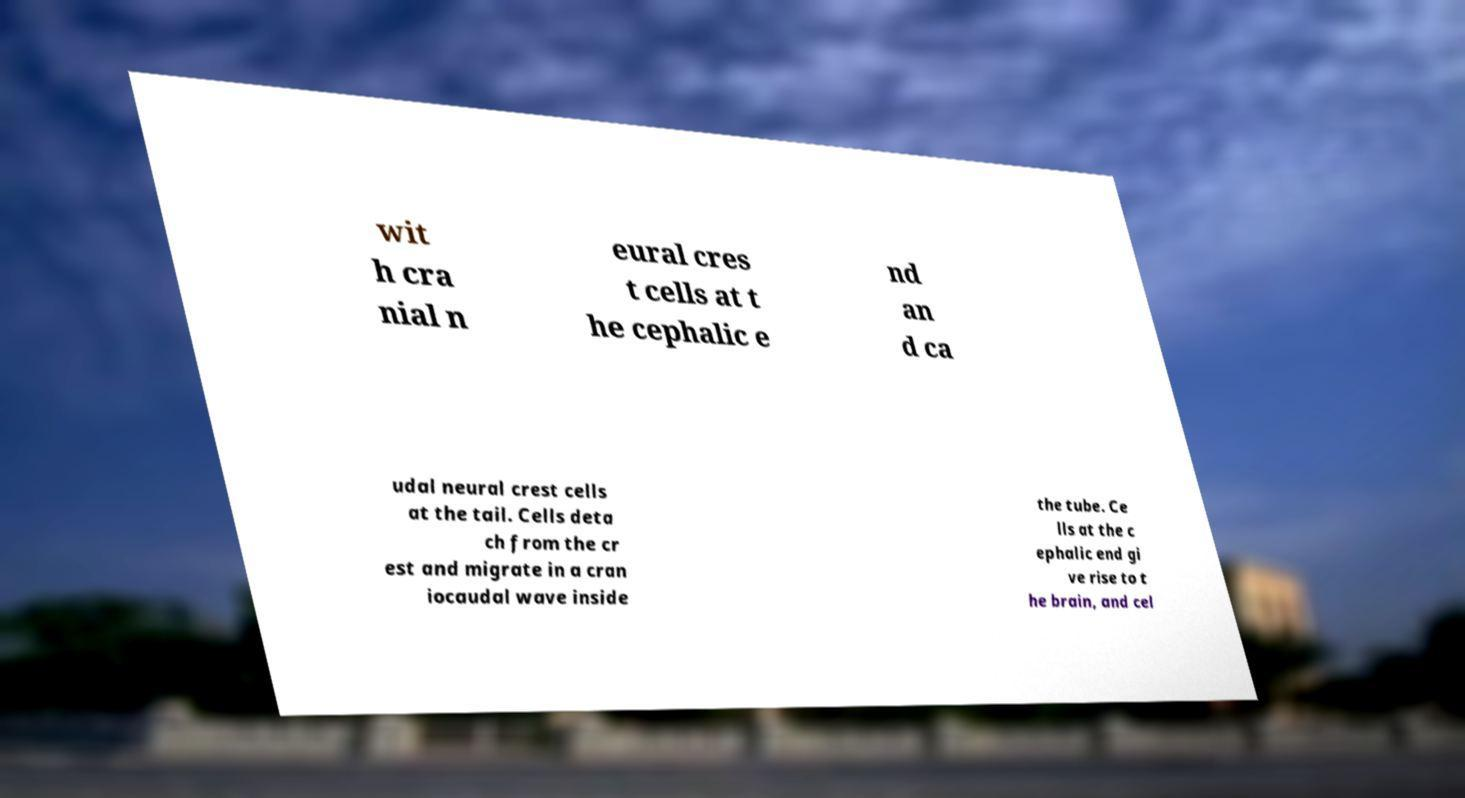Can you read and provide the text displayed in the image?This photo seems to have some interesting text. Can you extract and type it out for me? wit h cra nial n eural cres t cells at t he cephalic e nd an d ca udal neural crest cells at the tail. Cells deta ch from the cr est and migrate in a cran iocaudal wave inside the tube. Ce lls at the c ephalic end gi ve rise to t he brain, and cel 